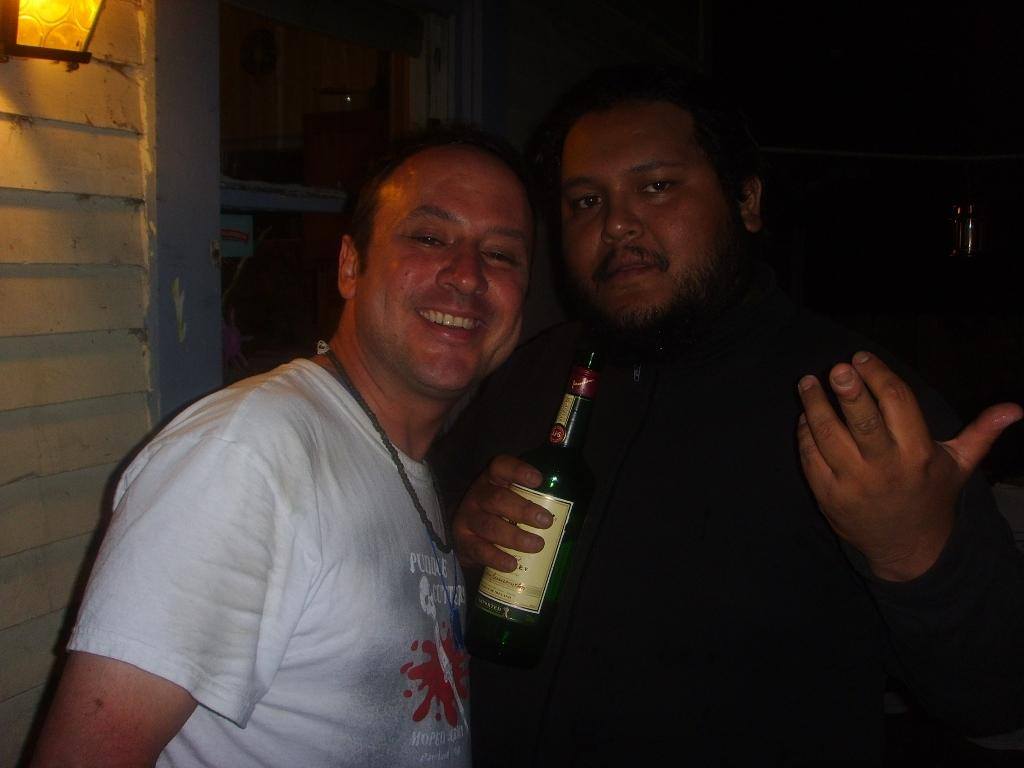How many people are in the image? There are two people in the image. What is the facial expression of one of the people? One of the people is smiling. What is the person holding in his hand? The person is holding a wine bottle in his hand. What is located on the left side of the image? There is a wall on the left side of the image, and a light at the top of the left side of the image. What type of butter is being used as bait in the image? There is no butter or bait present in the image; it features two people, one of whom is holding a wine bottle. 